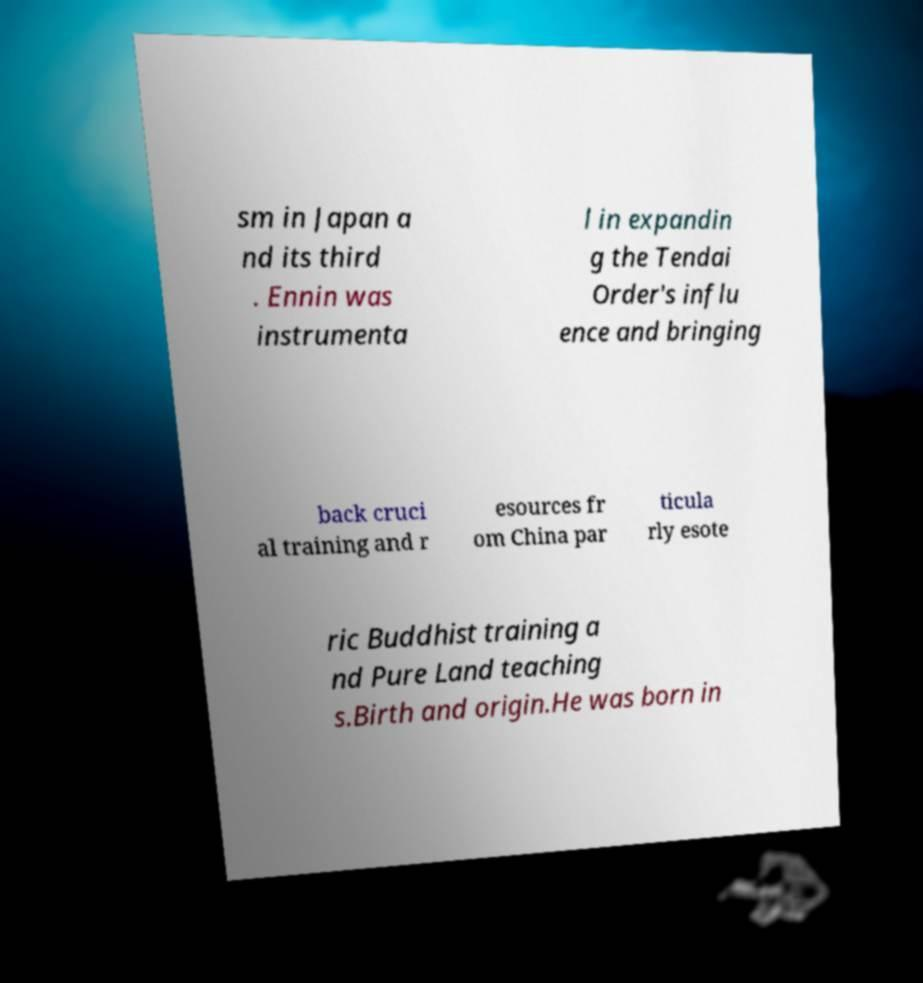I need the written content from this picture converted into text. Can you do that? sm in Japan a nd its third . Ennin was instrumenta l in expandin g the Tendai Order's influ ence and bringing back cruci al training and r esources fr om China par ticula rly esote ric Buddhist training a nd Pure Land teaching s.Birth and origin.He was born in 